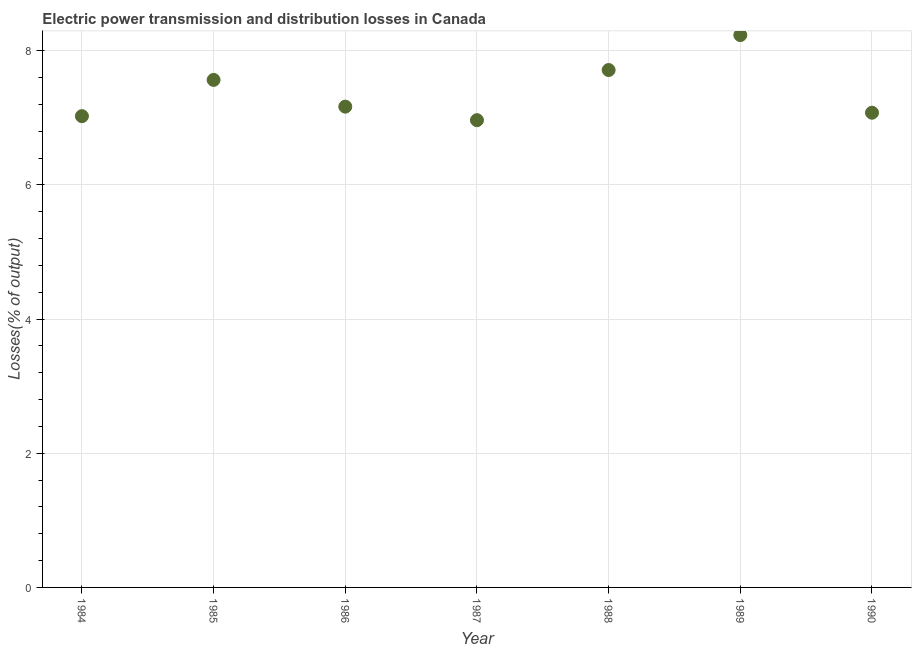What is the electric power transmission and distribution losses in 1987?
Ensure brevity in your answer.  6.96. Across all years, what is the maximum electric power transmission and distribution losses?
Your answer should be very brief. 8.23. Across all years, what is the minimum electric power transmission and distribution losses?
Make the answer very short. 6.96. In which year was the electric power transmission and distribution losses maximum?
Make the answer very short. 1989. What is the sum of the electric power transmission and distribution losses?
Make the answer very short. 51.74. What is the difference between the electric power transmission and distribution losses in 1986 and 1988?
Your response must be concise. -0.55. What is the average electric power transmission and distribution losses per year?
Offer a very short reply. 7.39. What is the median electric power transmission and distribution losses?
Your answer should be very brief. 7.17. In how many years, is the electric power transmission and distribution losses greater than 7.2 %?
Keep it short and to the point. 3. Do a majority of the years between 1990 and 1989 (inclusive) have electric power transmission and distribution losses greater than 5.2 %?
Offer a very short reply. No. What is the ratio of the electric power transmission and distribution losses in 1984 to that in 1985?
Your answer should be very brief. 0.93. Is the difference between the electric power transmission and distribution losses in 1986 and 1989 greater than the difference between any two years?
Ensure brevity in your answer.  No. What is the difference between the highest and the second highest electric power transmission and distribution losses?
Make the answer very short. 0.52. What is the difference between the highest and the lowest electric power transmission and distribution losses?
Ensure brevity in your answer.  1.27. Does the electric power transmission and distribution losses monotonically increase over the years?
Your answer should be very brief. No. How many dotlines are there?
Give a very brief answer. 1. What is the title of the graph?
Keep it short and to the point. Electric power transmission and distribution losses in Canada. What is the label or title of the Y-axis?
Ensure brevity in your answer.  Losses(% of output). What is the Losses(% of output) in 1984?
Offer a very short reply. 7.02. What is the Losses(% of output) in 1985?
Give a very brief answer. 7.57. What is the Losses(% of output) in 1986?
Make the answer very short. 7.17. What is the Losses(% of output) in 1987?
Offer a terse response. 6.96. What is the Losses(% of output) in 1988?
Ensure brevity in your answer.  7.71. What is the Losses(% of output) in 1989?
Give a very brief answer. 8.23. What is the Losses(% of output) in 1990?
Provide a succinct answer. 7.08. What is the difference between the Losses(% of output) in 1984 and 1985?
Make the answer very short. -0.54. What is the difference between the Losses(% of output) in 1984 and 1986?
Your response must be concise. -0.14. What is the difference between the Losses(% of output) in 1984 and 1987?
Your answer should be compact. 0.06. What is the difference between the Losses(% of output) in 1984 and 1988?
Your response must be concise. -0.69. What is the difference between the Losses(% of output) in 1984 and 1989?
Make the answer very short. -1.21. What is the difference between the Losses(% of output) in 1984 and 1990?
Your answer should be very brief. -0.05. What is the difference between the Losses(% of output) in 1985 and 1986?
Ensure brevity in your answer.  0.4. What is the difference between the Losses(% of output) in 1985 and 1987?
Ensure brevity in your answer.  0.6. What is the difference between the Losses(% of output) in 1985 and 1988?
Ensure brevity in your answer.  -0.15. What is the difference between the Losses(% of output) in 1985 and 1989?
Provide a succinct answer. -0.67. What is the difference between the Losses(% of output) in 1985 and 1990?
Your answer should be compact. 0.49. What is the difference between the Losses(% of output) in 1986 and 1987?
Give a very brief answer. 0.2. What is the difference between the Losses(% of output) in 1986 and 1988?
Provide a short and direct response. -0.55. What is the difference between the Losses(% of output) in 1986 and 1989?
Keep it short and to the point. -1.07. What is the difference between the Losses(% of output) in 1986 and 1990?
Offer a very short reply. 0.09. What is the difference between the Losses(% of output) in 1987 and 1988?
Give a very brief answer. -0.75. What is the difference between the Losses(% of output) in 1987 and 1989?
Keep it short and to the point. -1.27. What is the difference between the Losses(% of output) in 1987 and 1990?
Offer a terse response. -0.11. What is the difference between the Losses(% of output) in 1988 and 1989?
Provide a short and direct response. -0.52. What is the difference between the Losses(% of output) in 1988 and 1990?
Make the answer very short. 0.64. What is the difference between the Losses(% of output) in 1989 and 1990?
Provide a succinct answer. 1.16. What is the ratio of the Losses(% of output) in 1984 to that in 1985?
Make the answer very short. 0.93. What is the ratio of the Losses(% of output) in 1984 to that in 1988?
Provide a succinct answer. 0.91. What is the ratio of the Losses(% of output) in 1984 to that in 1989?
Your answer should be very brief. 0.85. What is the ratio of the Losses(% of output) in 1984 to that in 1990?
Give a very brief answer. 0.99. What is the ratio of the Losses(% of output) in 1985 to that in 1986?
Your response must be concise. 1.06. What is the ratio of the Losses(% of output) in 1985 to that in 1987?
Offer a very short reply. 1.09. What is the ratio of the Losses(% of output) in 1985 to that in 1989?
Your answer should be very brief. 0.92. What is the ratio of the Losses(% of output) in 1985 to that in 1990?
Ensure brevity in your answer.  1.07. What is the ratio of the Losses(% of output) in 1986 to that in 1988?
Offer a terse response. 0.93. What is the ratio of the Losses(% of output) in 1986 to that in 1989?
Provide a succinct answer. 0.87. What is the ratio of the Losses(% of output) in 1987 to that in 1988?
Give a very brief answer. 0.9. What is the ratio of the Losses(% of output) in 1987 to that in 1989?
Make the answer very short. 0.85. What is the ratio of the Losses(% of output) in 1987 to that in 1990?
Give a very brief answer. 0.98. What is the ratio of the Losses(% of output) in 1988 to that in 1989?
Make the answer very short. 0.94. What is the ratio of the Losses(% of output) in 1988 to that in 1990?
Provide a short and direct response. 1.09. What is the ratio of the Losses(% of output) in 1989 to that in 1990?
Make the answer very short. 1.16. 